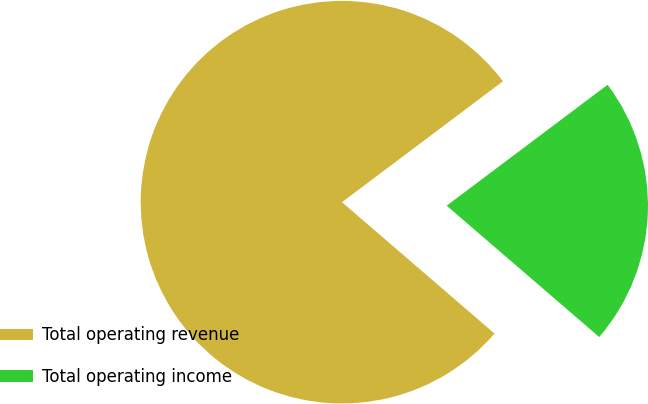<chart> <loc_0><loc_0><loc_500><loc_500><pie_chart><fcel>Total operating revenue<fcel>Total operating income<nl><fcel>78.43%<fcel>21.57%<nl></chart> 